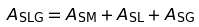Convert formula to latex. <formula><loc_0><loc_0><loc_500><loc_500>A _ { \text {SLG} } = A _ { \text {SM} } + A _ { \text {SL} } + A _ { \text {SG} }</formula> 